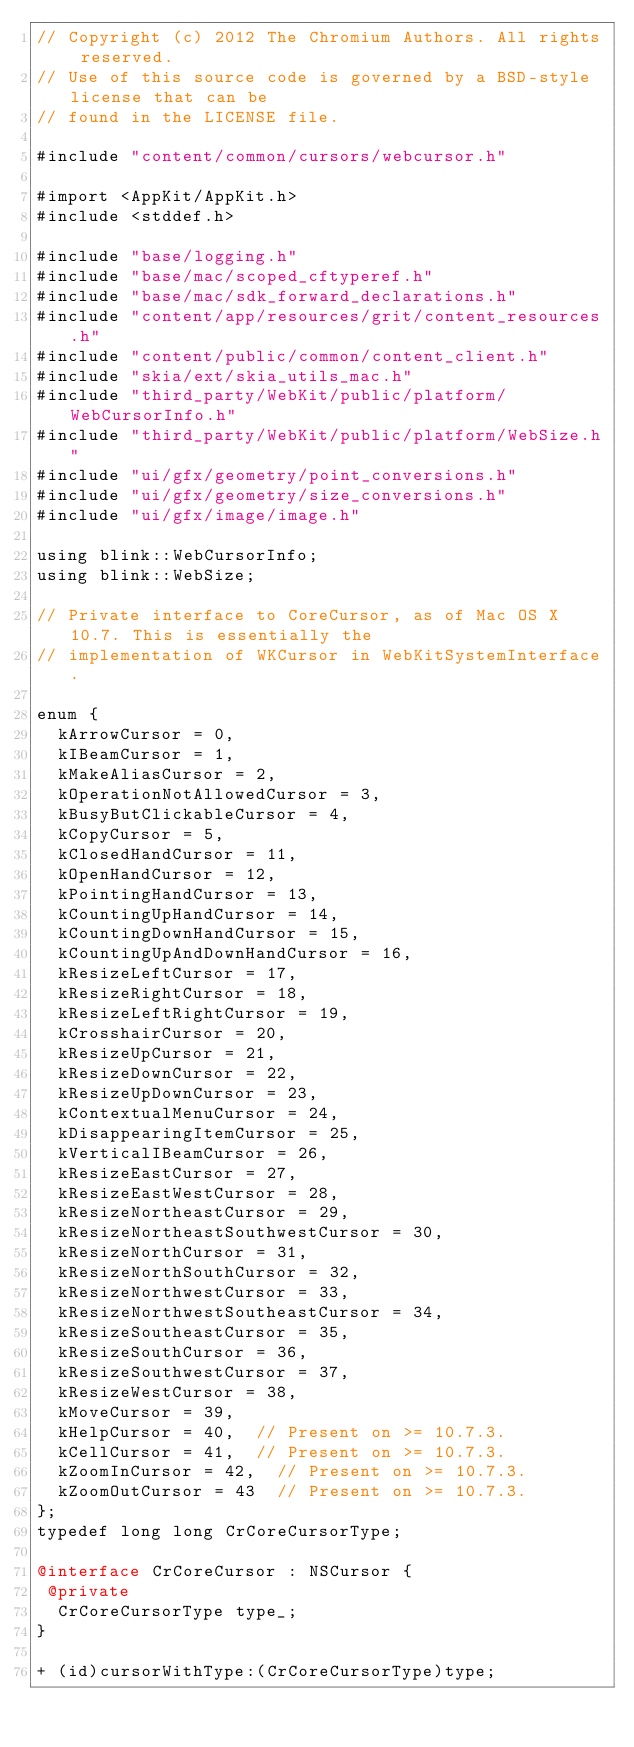Convert code to text. <code><loc_0><loc_0><loc_500><loc_500><_ObjectiveC_>// Copyright (c) 2012 The Chromium Authors. All rights reserved.
// Use of this source code is governed by a BSD-style license that can be
// found in the LICENSE file.

#include "content/common/cursors/webcursor.h"

#import <AppKit/AppKit.h>
#include <stddef.h>

#include "base/logging.h"
#include "base/mac/scoped_cftyperef.h"
#include "base/mac/sdk_forward_declarations.h"
#include "content/app/resources/grit/content_resources.h"
#include "content/public/common/content_client.h"
#include "skia/ext/skia_utils_mac.h"
#include "third_party/WebKit/public/platform/WebCursorInfo.h"
#include "third_party/WebKit/public/platform/WebSize.h"
#include "ui/gfx/geometry/point_conversions.h"
#include "ui/gfx/geometry/size_conversions.h"
#include "ui/gfx/image/image.h"

using blink::WebCursorInfo;
using blink::WebSize;

// Private interface to CoreCursor, as of Mac OS X 10.7. This is essentially the
// implementation of WKCursor in WebKitSystemInterface.

enum {
  kArrowCursor = 0,
  kIBeamCursor = 1,
  kMakeAliasCursor = 2,
  kOperationNotAllowedCursor = 3,
  kBusyButClickableCursor = 4,
  kCopyCursor = 5,
  kClosedHandCursor = 11,
  kOpenHandCursor = 12,
  kPointingHandCursor = 13,
  kCountingUpHandCursor = 14,
  kCountingDownHandCursor = 15,
  kCountingUpAndDownHandCursor = 16,
  kResizeLeftCursor = 17,
  kResizeRightCursor = 18,
  kResizeLeftRightCursor = 19,
  kCrosshairCursor = 20,
  kResizeUpCursor = 21,
  kResizeDownCursor = 22,
  kResizeUpDownCursor = 23,
  kContextualMenuCursor = 24,
  kDisappearingItemCursor = 25,
  kVerticalIBeamCursor = 26,
  kResizeEastCursor = 27,
  kResizeEastWestCursor = 28,
  kResizeNortheastCursor = 29,
  kResizeNortheastSouthwestCursor = 30,
  kResizeNorthCursor = 31,
  kResizeNorthSouthCursor = 32,
  kResizeNorthwestCursor = 33,
  kResizeNorthwestSoutheastCursor = 34,
  kResizeSoutheastCursor = 35,
  kResizeSouthCursor = 36,
  kResizeSouthwestCursor = 37,
  kResizeWestCursor = 38,
  kMoveCursor = 39,
  kHelpCursor = 40,  // Present on >= 10.7.3.
  kCellCursor = 41,  // Present on >= 10.7.3.
  kZoomInCursor = 42,  // Present on >= 10.7.3.
  kZoomOutCursor = 43  // Present on >= 10.7.3.
};
typedef long long CrCoreCursorType;

@interface CrCoreCursor : NSCursor {
 @private
  CrCoreCursorType type_;
}

+ (id)cursorWithType:(CrCoreCursorType)type;</code> 